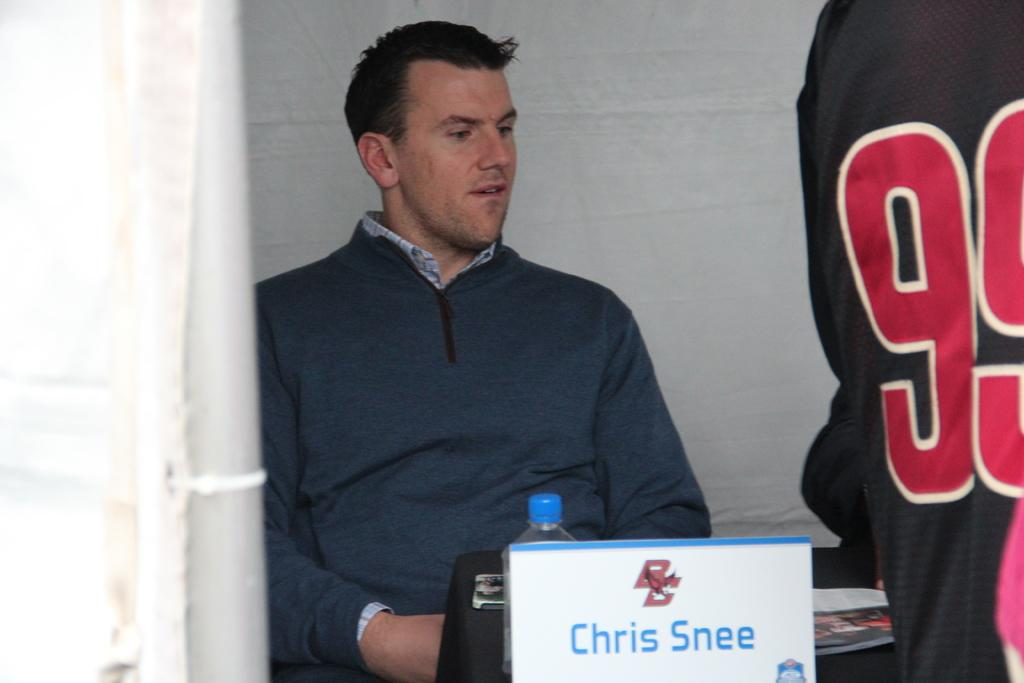<image>
Share a concise interpretation of the image provided. Chris Snee is sitting at a table near someone wearing the number 99. 